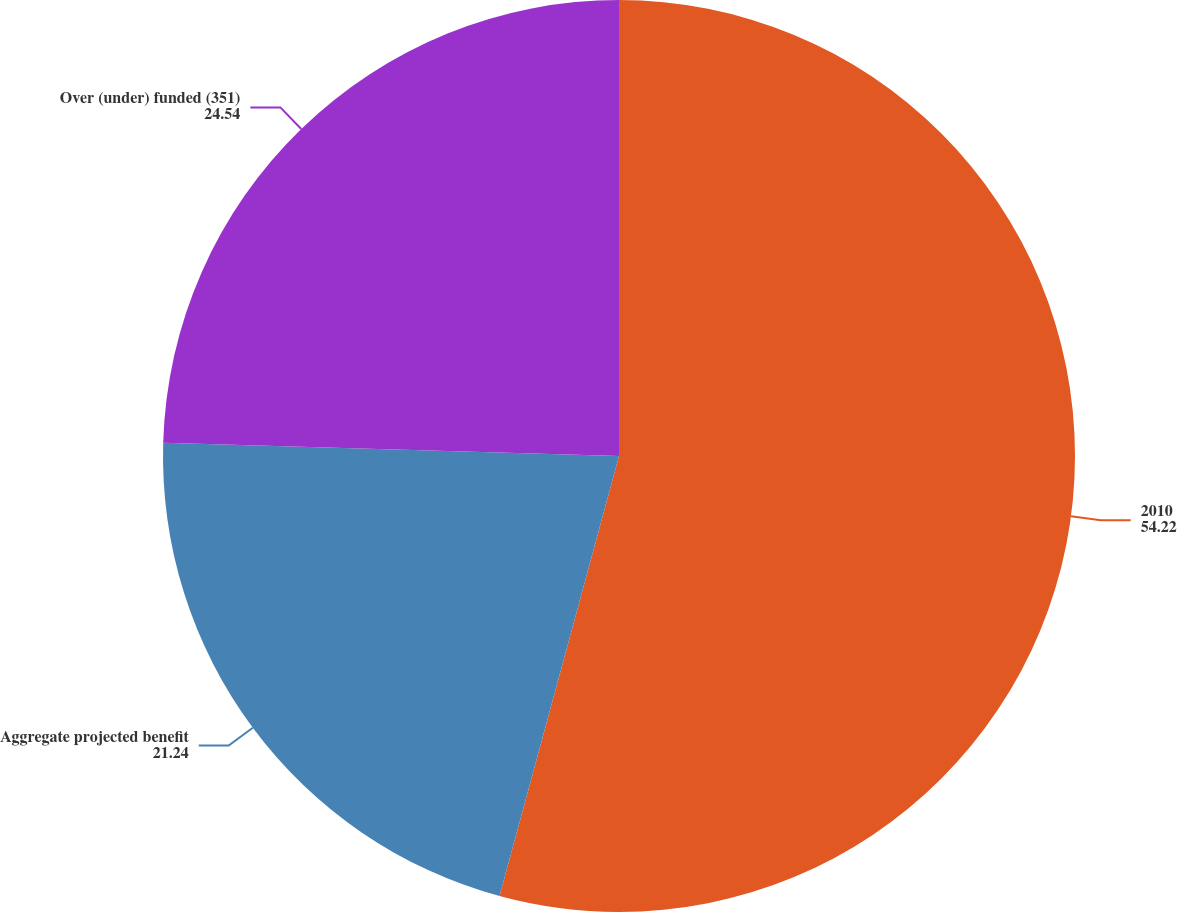Convert chart. <chart><loc_0><loc_0><loc_500><loc_500><pie_chart><fcel>2010<fcel>Aggregate projected benefit<fcel>Over (under) funded (351)<nl><fcel>54.22%<fcel>21.24%<fcel>24.54%<nl></chart> 